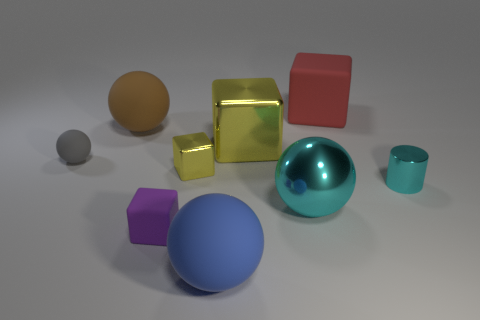Subtract all small yellow cubes. How many cubes are left? 3 Subtract 1 cubes. How many cubes are left? 3 Add 1 large gray objects. How many objects exist? 10 Subtract all cyan blocks. Subtract all green cylinders. How many blocks are left? 4 Subtract all balls. How many objects are left? 5 Add 6 big rubber spheres. How many big rubber spheres are left? 8 Add 5 tiny red metal objects. How many tiny red metal objects exist? 5 Subtract 0 yellow balls. How many objects are left? 9 Subtract all tiny gray rubber balls. Subtract all big yellow things. How many objects are left? 7 